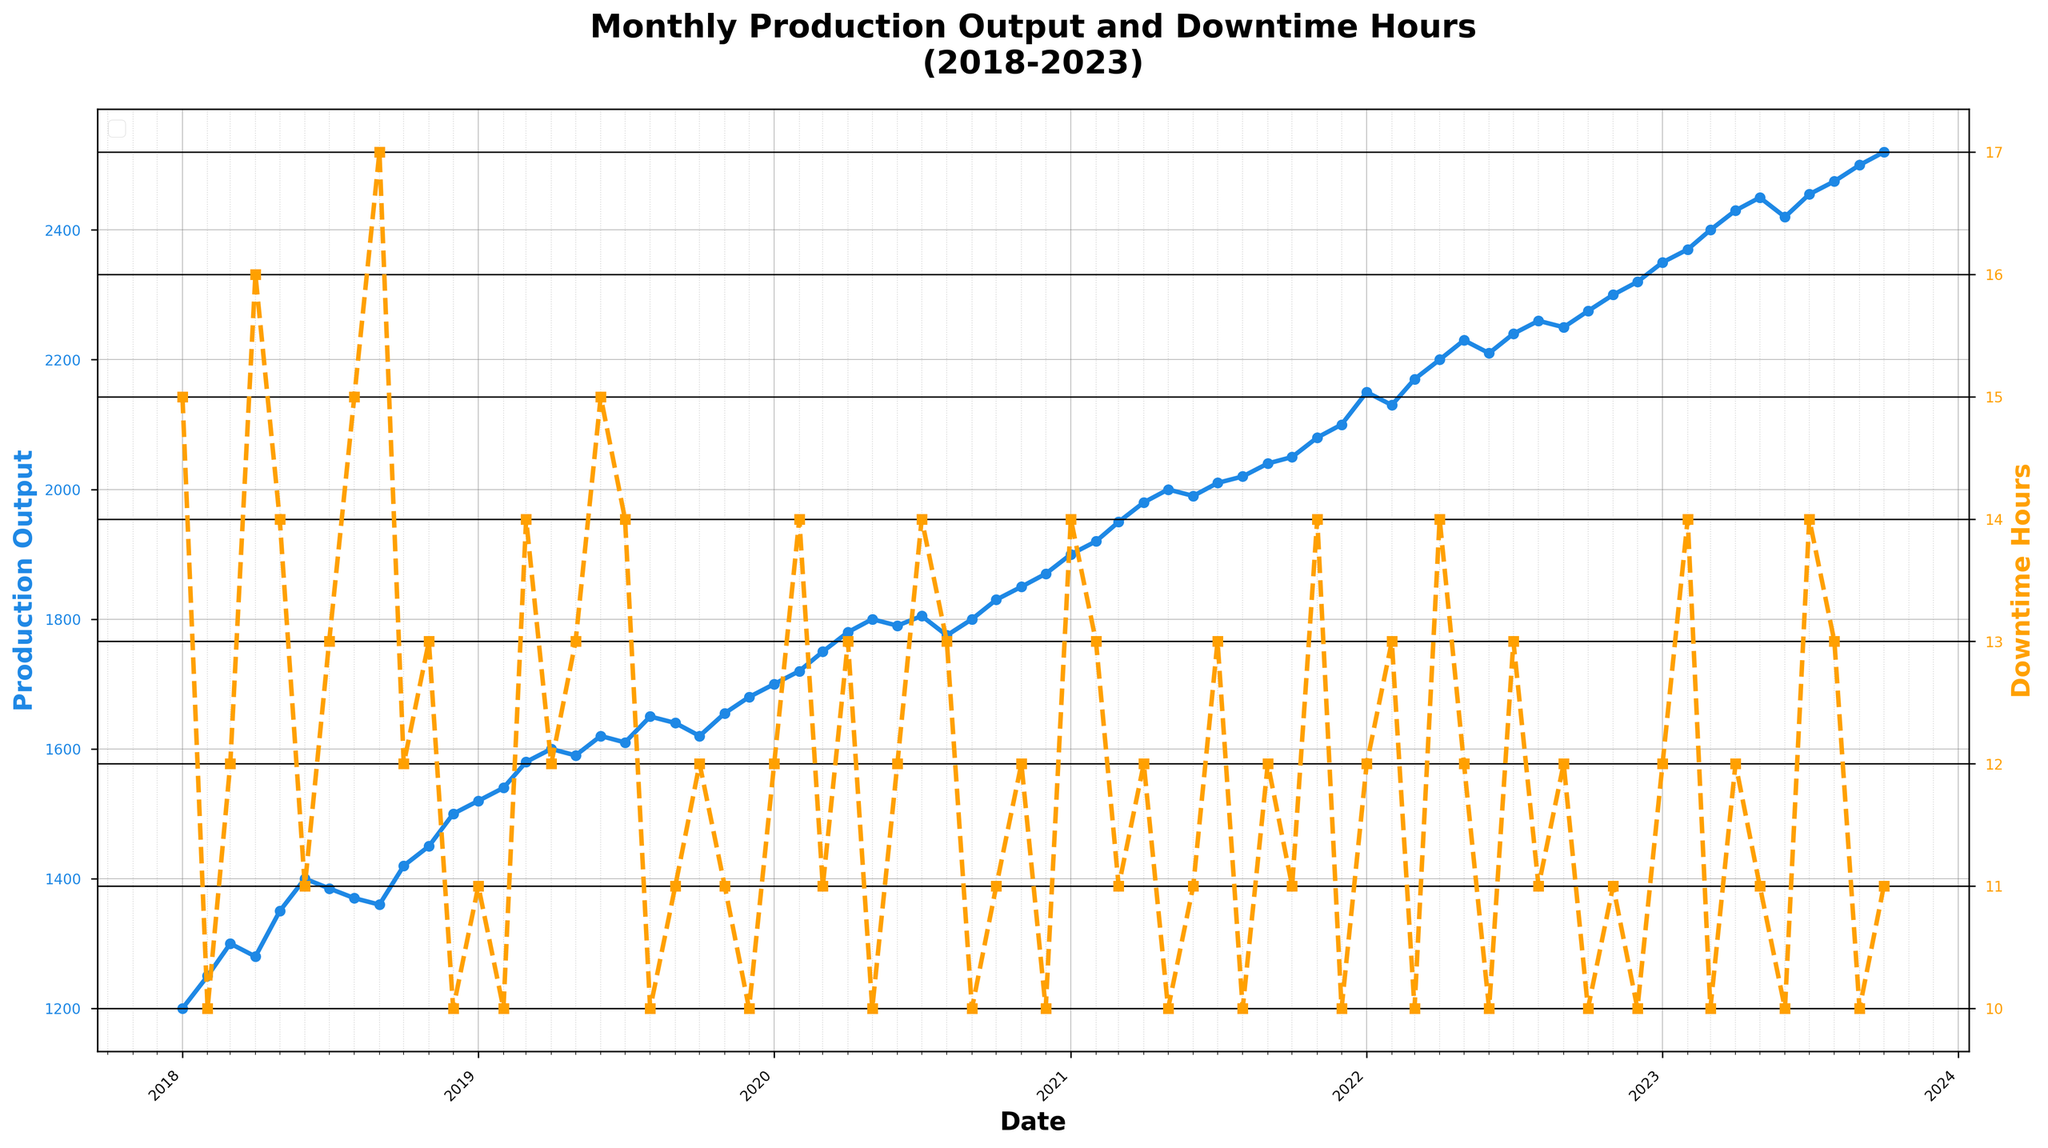What is the title of the plot? The title of the plot is displayed at the top of the figure, reading 'Monthly Production Output and Downtime Hours (2018-2023)'.
Answer: Monthly Production Output and Downtime Hours (2018-2023) What are the labels of the two y-axes? The left y-axis is labeled 'Production Output', and the right y-axis is labeled 'Downtime Hours'.
Answer: Production Output and Downtime Hours Which year had the highest production output? By examining the plot, we can see that the highest production output value is in October 2023.
Answer: 2023 During which month and year was the downtime hours the lowest? The points on the secondary y-axis (right axis) represent downtime hours. The lowest value, 10 hours, can be seen in multiple months including February 2018, May 2020, December 2020, May 2021, August 2021, June 2022, December 2022, and several months in 2023. An example is December 2018.
Answer: December 2018 How does the production output in January 2023 compare to January 2018? To compare, check the values for both months. January 2018 has a production output of 1200 units, while January 2023 has 2350 units. 2350 is greater than 1200, indicating an increase.
Answer: Increased Did downtime hours show any noticeable trend over the past five years? By observing the downtime hours represented by the dashed line in the plot, it does not show a clear upward or downward trend but fluctuates around an average range.
Answer: No clear trend In which year did production output consistently exceed 2000 units? Examine the plot for the period when the production output line stays above 2000 units. This continuous increase occurs in 2021 and beyond.
Answer: 2021 What is the production output in March 2020 and March 2021, and what is the difference between them? March 2020 has a production output of 1750 units, and March 2021 has 1950 units. The difference is calculated as 1950 - 1750 = 200.
Answer: 200 units When were the downtime hours and production output closest to their average values? The average can be approximated by visually identifying months where both the production output and downtime appear neither too high nor too low. This is an approximate task, but a reasonable choice could be mid-2020.
Answer: Mid-2020 